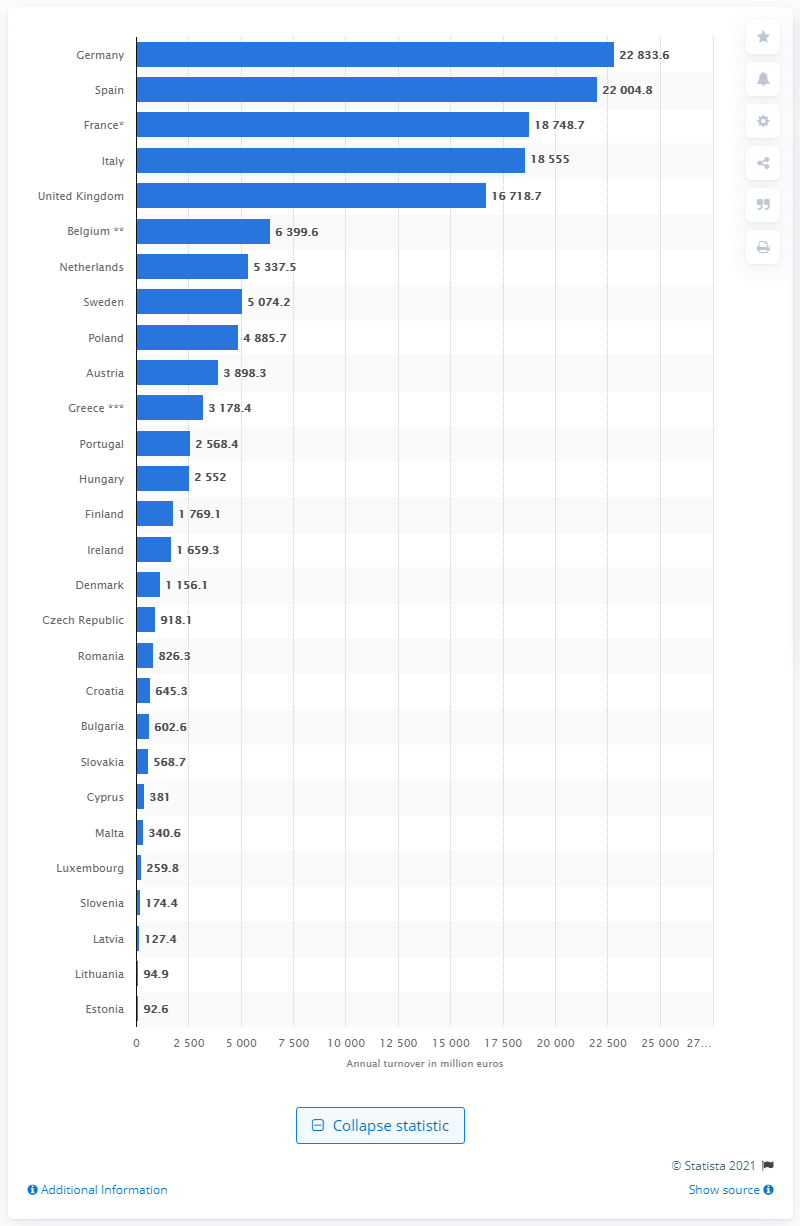Outline some significant characteristics in this image. In 2015, Germany's turnover was 22,833.6 million. 